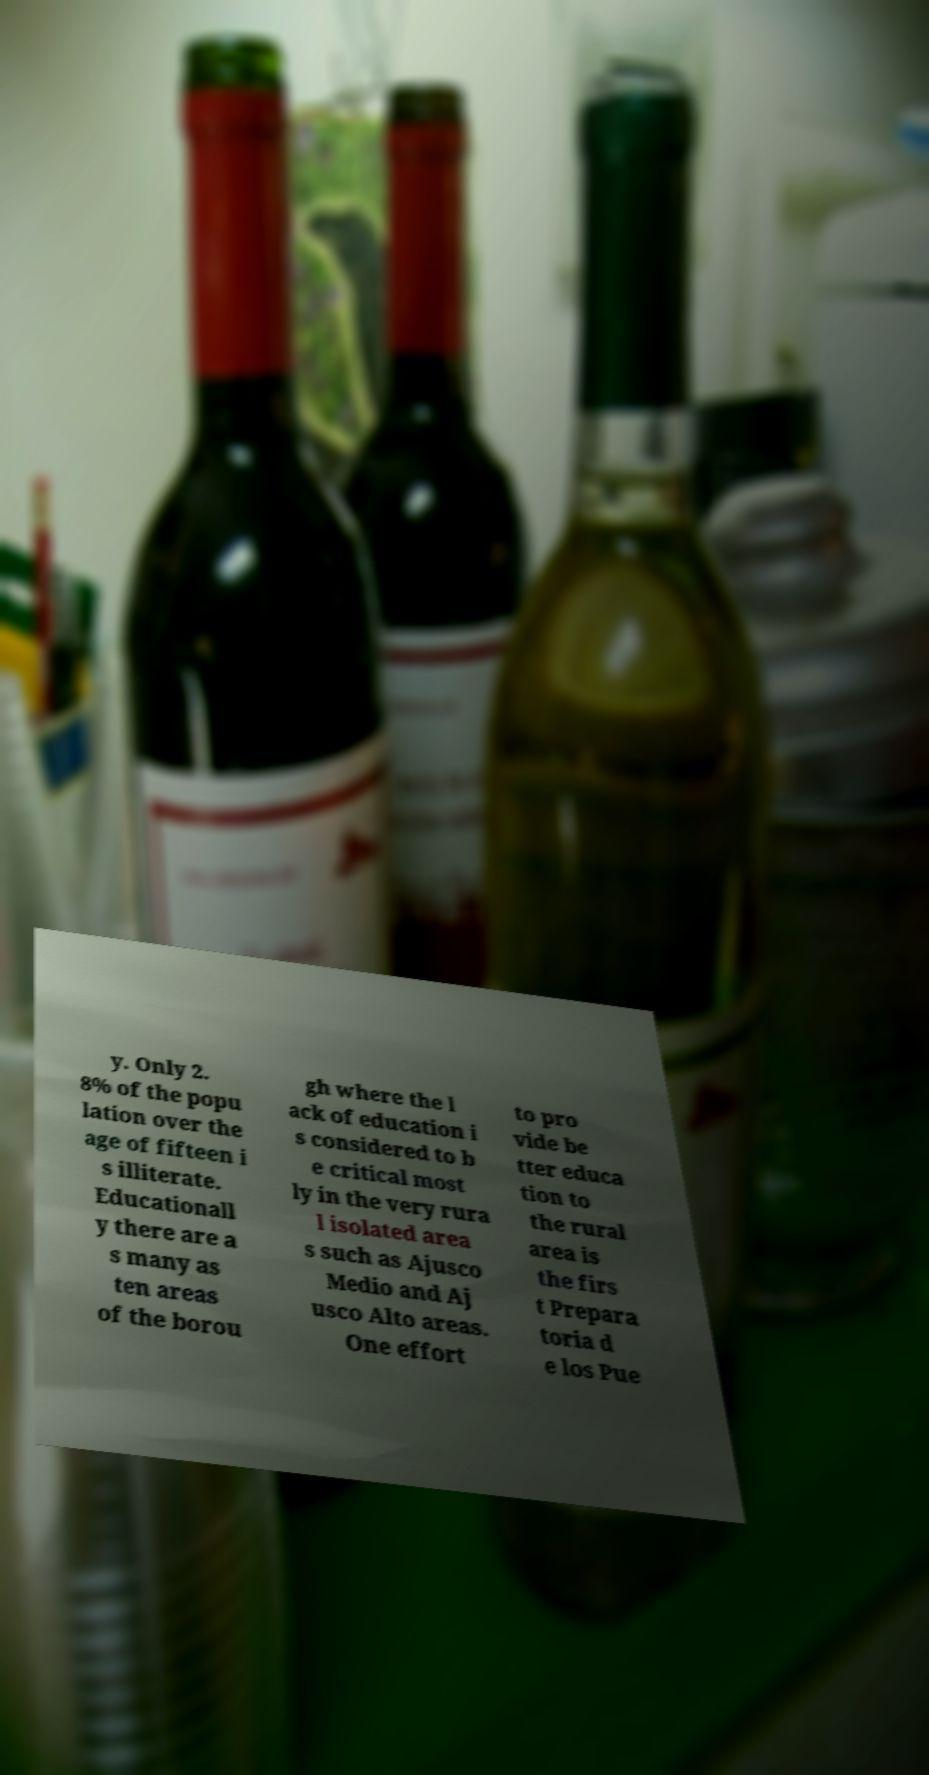Could you extract and type out the text from this image? y. Only 2. 8% of the popu lation over the age of fifteen i s illiterate. Educationall y there are a s many as ten areas of the borou gh where the l ack of education i s considered to b e critical most ly in the very rura l isolated area s such as Ajusco Medio and Aj usco Alto areas. One effort to pro vide be tter educa tion to the rural area is the firs t Prepara toria d e los Pue 